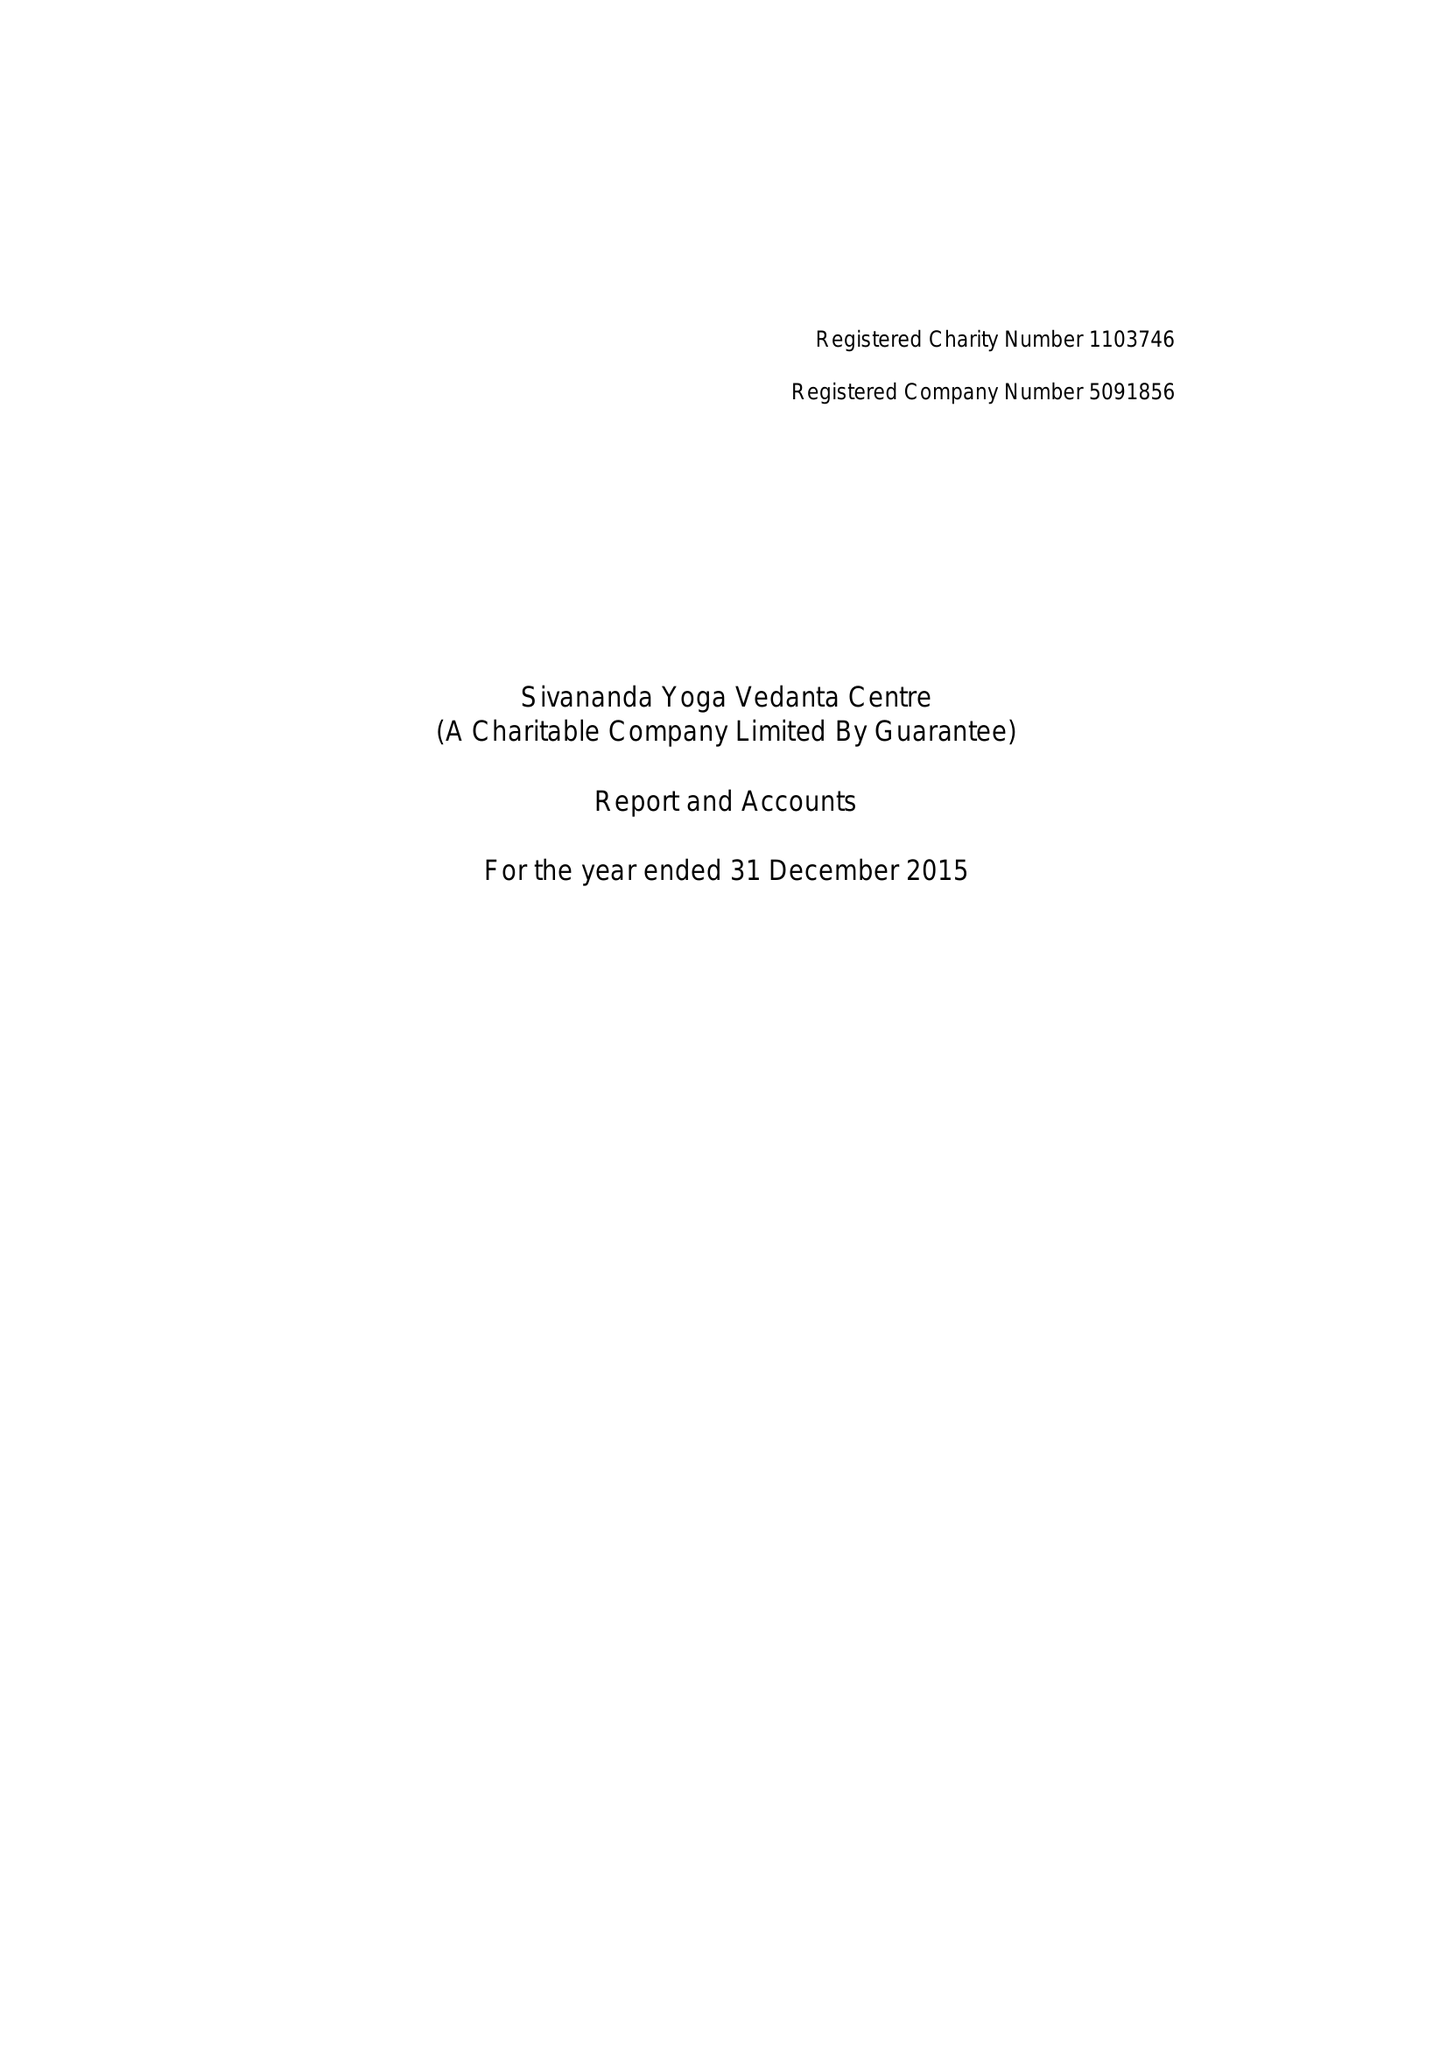What is the value for the charity_number?
Answer the question using a single word or phrase. 1103746 